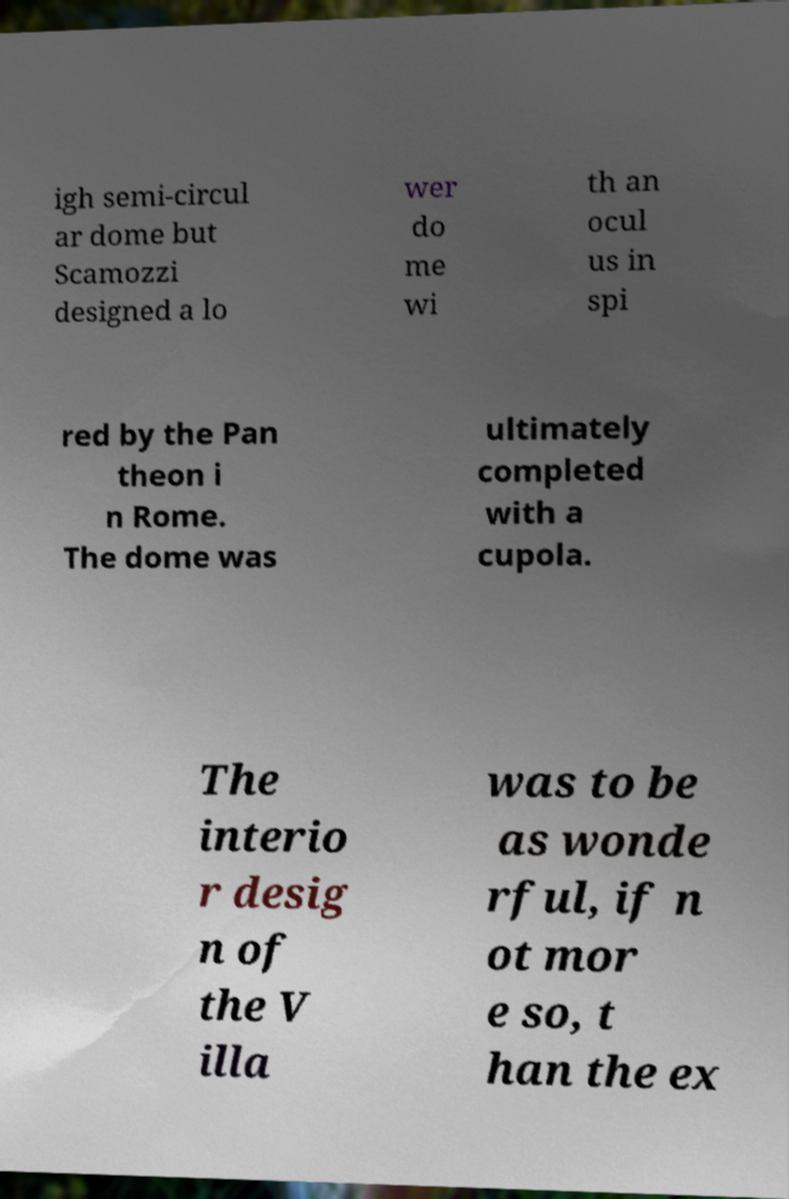Can you accurately transcribe the text from the provided image for me? igh semi-circul ar dome but Scamozzi designed a lo wer do me wi th an ocul us in spi red by the Pan theon i n Rome. The dome was ultimately completed with a cupola. The interio r desig n of the V illa was to be as wonde rful, if n ot mor e so, t han the ex 